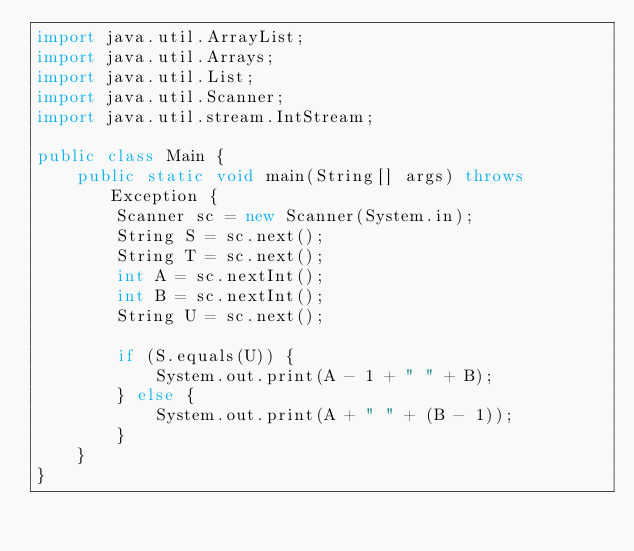Convert code to text. <code><loc_0><loc_0><loc_500><loc_500><_Java_>import java.util.ArrayList;
import java.util.Arrays;
import java.util.List;
import java.util.Scanner;
import java.util.stream.IntStream;

public class Main {
	public static void main(String[] args) throws Exception {
		Scanner sc = new Scanner(System.in);
		String S = sc.next();
		String T = sc.next();
		int A = sc.nextInt();
		int B = sc.nextInt();
		String U = sc.next();

		if (S.equals(U)) {
			System.out.print(A - 1 + " " + B);
		} else {
			System.out.print(A + " " + (B - 1));
		}
	}
}</code> 